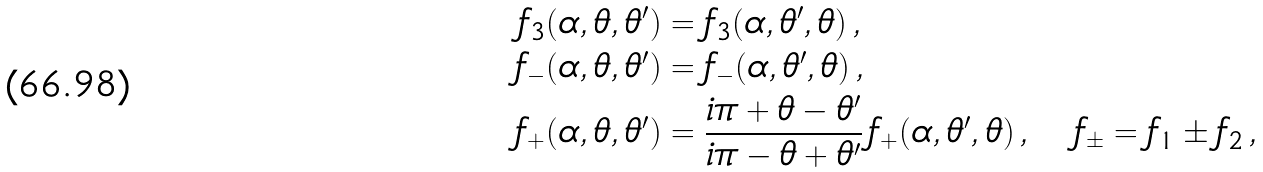<formula> <loc_0><loc_0><loc_500><loc_500>f _ { 3 } ( \alpha , \theta , \theta ^ { \prime } ) & = f _ { 3 } ( \alpha , \theta ^ { \prime } , \theta ) \, , \\ f _ { - } ( \alpha , \theta , \theta ^ { \prime } ) & = f _ { - } ( \alpha , \theta ^ { \prime } , \theta ) \, , \\ f _ { + } ( \alpha , \theta , \theta ^ { \prime } ) & = \frac { i \pi + \theta - \theta ^ { \prime } } { i \pi - \theta + \theta ^ { \prime } } \, f _ { + } ( \alpha , \theta ^ { \prime } , \theta ) \, , \quad f _ { \pm } = f _ { 1 } \pm f _ { 2 } \, ,</formula> 